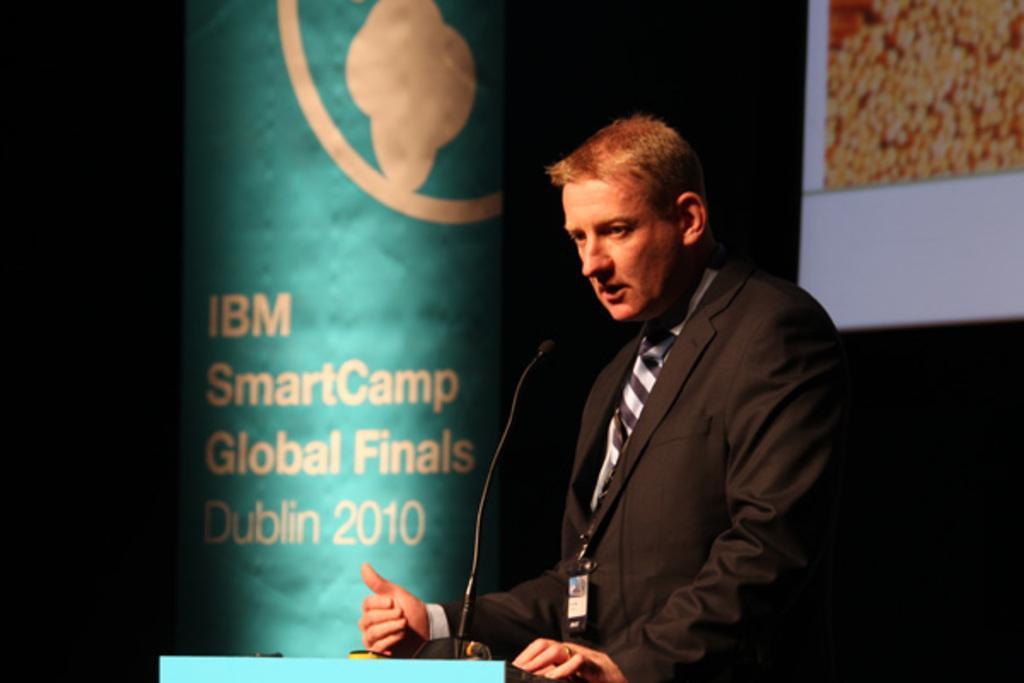Please provide a concise description of this image. In the picture we can see a man standing near the desk and talking in the microphone which is to the desk and man is in black color blazer, tie and ID card and beside them, we can see a pillar which is blue in color with something written on it and behind the man we can see a wall with a screen. 